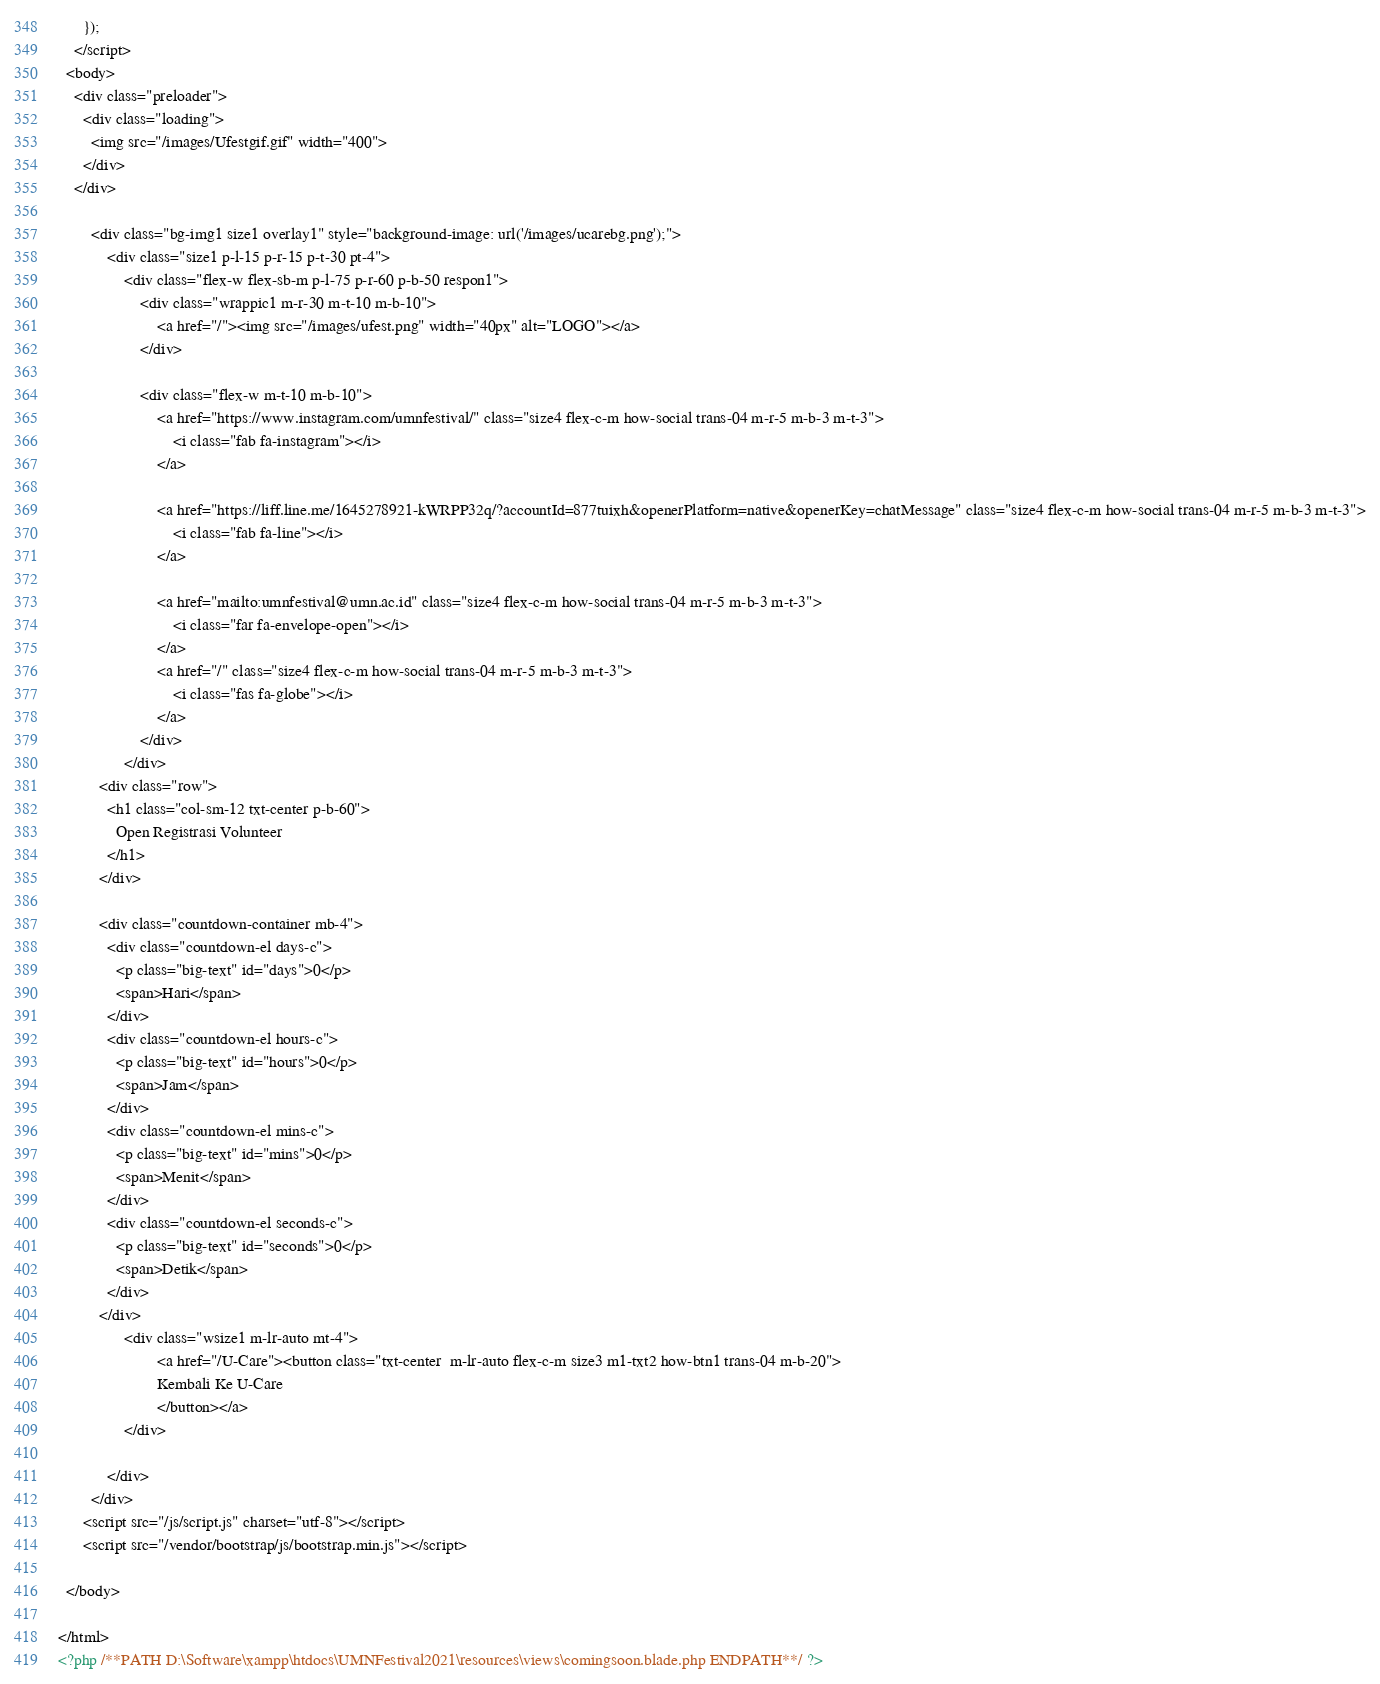<code> <loc_0><loc_0><loc_500><loc_500><_PHP_>      });
    </script>
  <body>
    <div class="preloader">
      <div class="loading">
        <img src="/images/Ufestgif.gif" width="400">
      </div>
    </div>

    	<div class="bg-img1 size1 overlay1" style="background-image: url('/images/ucarebg.png');">
    		<div class="size1 p-l-15 p-r-15 p-t-30 pt-4">
    			<div class="flex-w flex-sb-m p-l-75 p-r-60 p-b-50 respon1">
    				<div class="wrappic1 m-r-30 m-t-10 m-b-10">
    					<a href="/"><img src="/images/ufest.png" width="40px" alt="LOGO"></a>
    				</div>

    				<div class="flex-w m-t-10 m-b-10">
    					<a href="https://www.instagram.com/umnfestival/" class="size4 flex-c-m how-social trans-04 m-r-5 m-b-3 m-t-3">
    						<i class="fab fa-instagram"></i>
    					</a>

    					<a href="https://liff.line.me/1645278921-kWRPP32q/?accountId=877tuixh&openerPlatform=native&openerKey=chatMessage" class="size4 flex-c-m how-social trans-04 m-r-5 m-b-3 m-t-3">
    						<i class="fab fa-line"></i>
    					</a>

    					<a href="mailto:umnfestival@umn.ac.id" class="size4 flex-c-m how-social trans-04 m-r-5 m-b-3 m-t-3">
    						<i class="far fa-envelope-open"></i>
    					</a>
    					<a href="/" class="size4 flex-c-m how-social trans-04 m-r-5 m-b-3 m-t-3">
    						<i class="fas fa-globe"></i>
    					</a>
    				</div>
    			</div>
          <div class="row">
            <h1 class="col-sm-12 txt-center p-b-60">
              Open Registrasi Volunteer
            </h1>
          </div>

          <div class="countdown-container mb-4">
            <div class="countdown-el days-c">
              <p class="big-text" id="days">0</p>
              <span>Hari</span>
            </div>
            <div class="countdown-el hours-c">
              <p class="big-text" id="hours">0</p>
              <span>Jam</span>
            </div>
            <div class="countdown-el mins-c">
              <p class="big-text" id="mins">0</p>
              <span>Menit</span>
            </div>
            <div class="countdown-el seconds-c">
              <p class="big-text" id="seconds">0</p>
              <span>Detik</span>
            </div>
          </div>
    			<div class="wsize1 m-lr-auto mt-4">
    					<a href="/U-Care"><button class="txt-center  m-lr-auto flex-c-m size3 m1-txt2 how-btn1 trans-04 m-b-20">
    					Kembali Ke U-Care
    					</button></a>
    			</div>

    		</div>
    	</div>
      <script src="/js/script.js" charset="utf-8"></script>
      <script src="/vendor/bootstrap/js/bootstrap.min.js"></script>

  </body>

</html>
<?php /**PATH D:\Software\xampp\htdocs\UMNFestival2021\resources\views\comingsoon.blade.php ENDPATH**/ ?></code> 